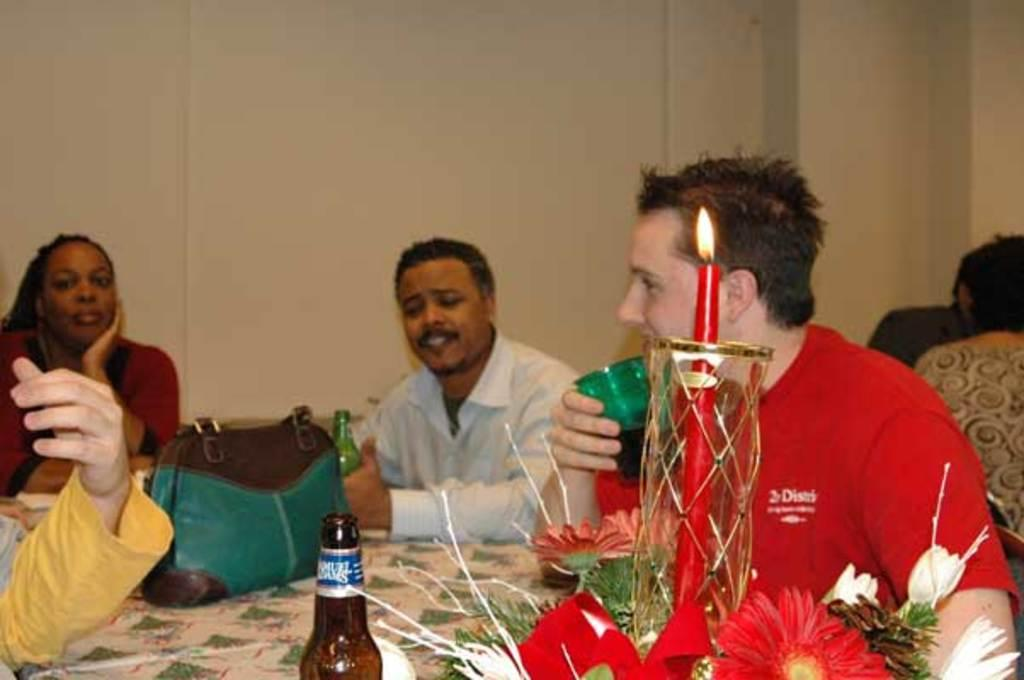What are the persons in the image doing? The persons in the image are sitting on chairs. What is in front of the persons? There is a table in front of the persons. What objects can be seen on the table? There is a bag, bottles, a bouquet, and a candle with light on the table. What is one person holding? One person is holding a glass. Can you see anyone attempting to pull a rifle in the image? There is no rifle or anyone attempting to pull one in the image. 